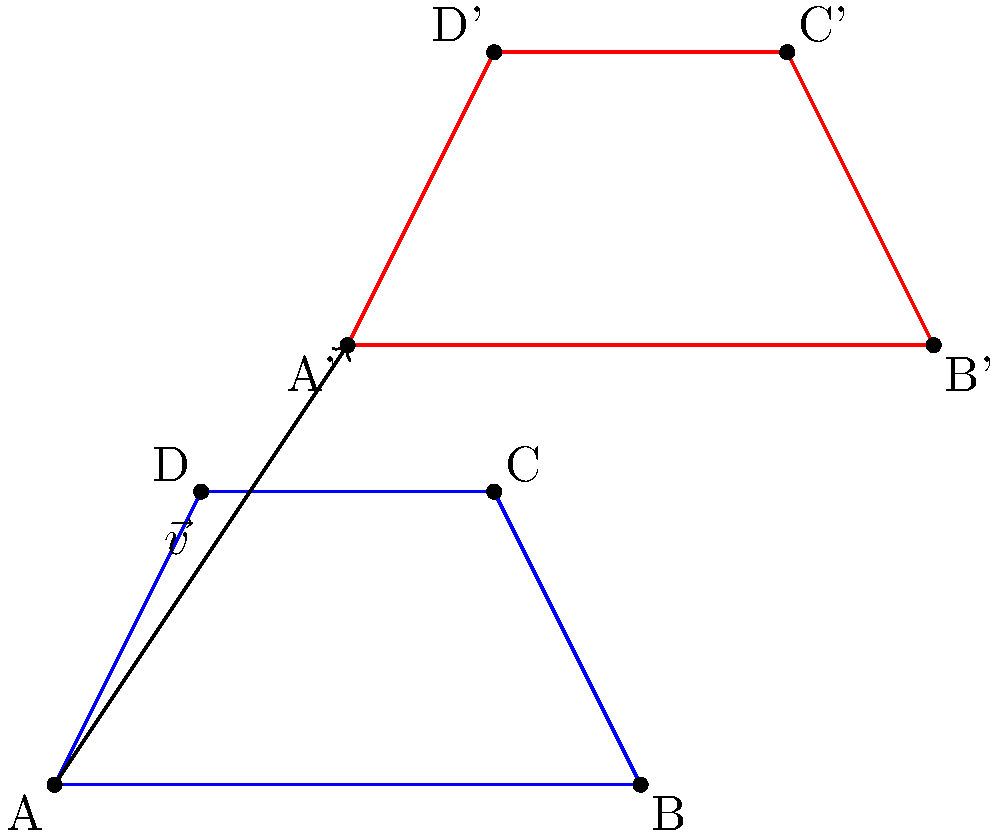In a Django-based geometry application, you're implementing a feature to translate shapes. Given a trapezoid ABCD with vertices A(0,0), B(4,0), C(3,2), and D(1,2), translate it by vector $\vec{v} = (2,3)$. What are the coordinates of vertex C' (the translated position of C) relative to the origin? To find the coordinates of C' after translation, we follow these steps:

1. Identify the original coordinates of C:
   C = (3, 2)

2. Identify the translation vector:
   $\vec{v} = (2, 3)$

3. To translate a point, we add the components of the translation vector to the coordinates of the original point:
   C' = C + $\vec{v}$
   C' = (3, 2) + (2, 3)

4. Perform the addition:
   x-coordinate of C': 3 + 2 = 5
   y-coordinate of C': 2 + 3 = 5

5. Therefore, the coordinates of C' are (5, 5)

This process is similar to how you might implement a translation function in Django, where you'd add the vector components to each vertex of a shape to get its new position.
Answer: (5, 5) 